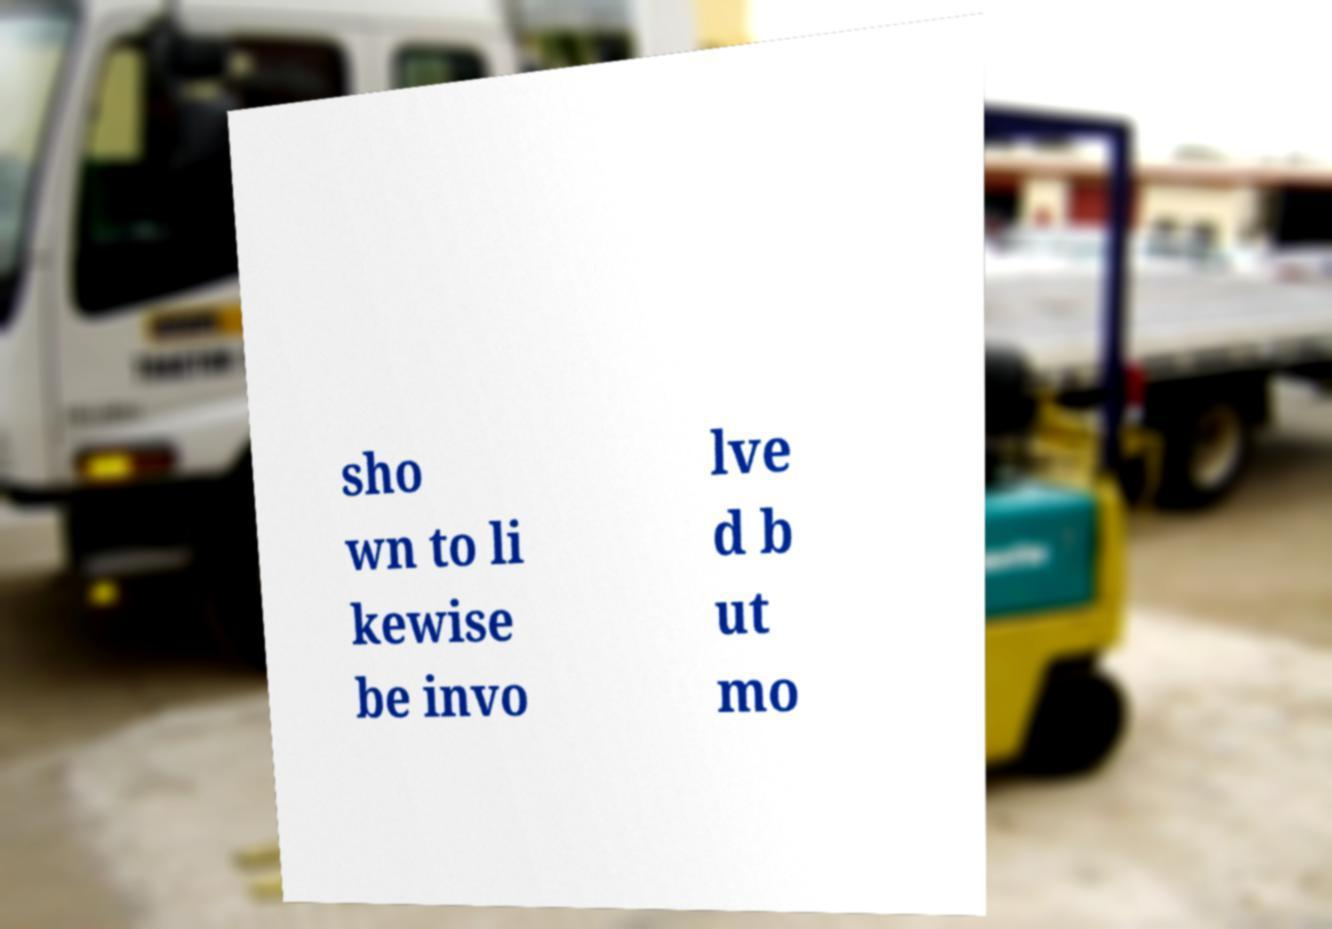For documentation purposes, I need the text within this image transcribed. Could you provide that? sho wn to li kewise be invo lve d b ut mo 